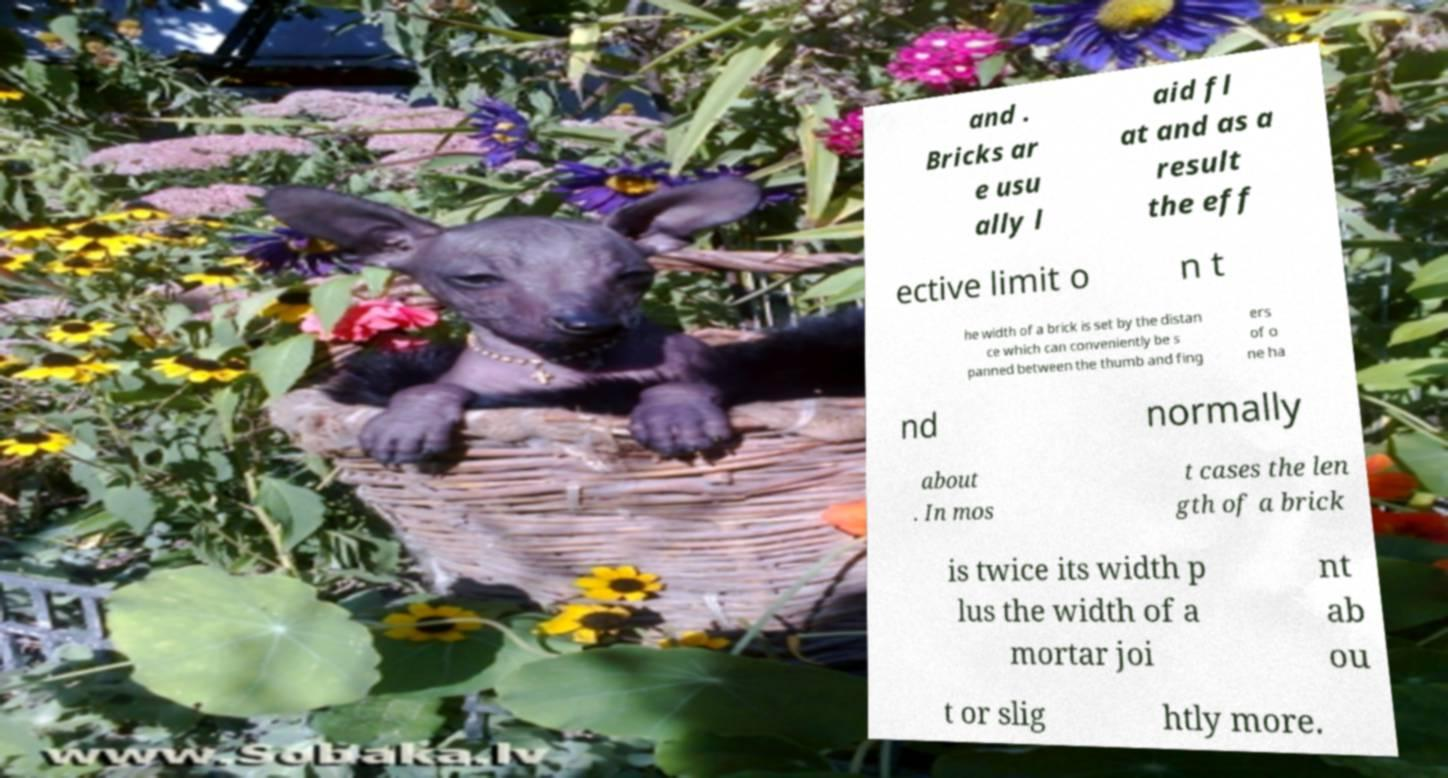Could you assist in decoding the text presented in this image and type it out clearly? and . Bricks ar e usu ally l aid fl at and as a result the eff ective limit o n t he width of a brick is set by the distan ce which can conveniently be s panned between the thumb and fing ers of o ne ha nd normally about . In mos t cases the len gth of a brick is twice its width p lus the width of a mortar joi nt ab ou t or slig htly more. 